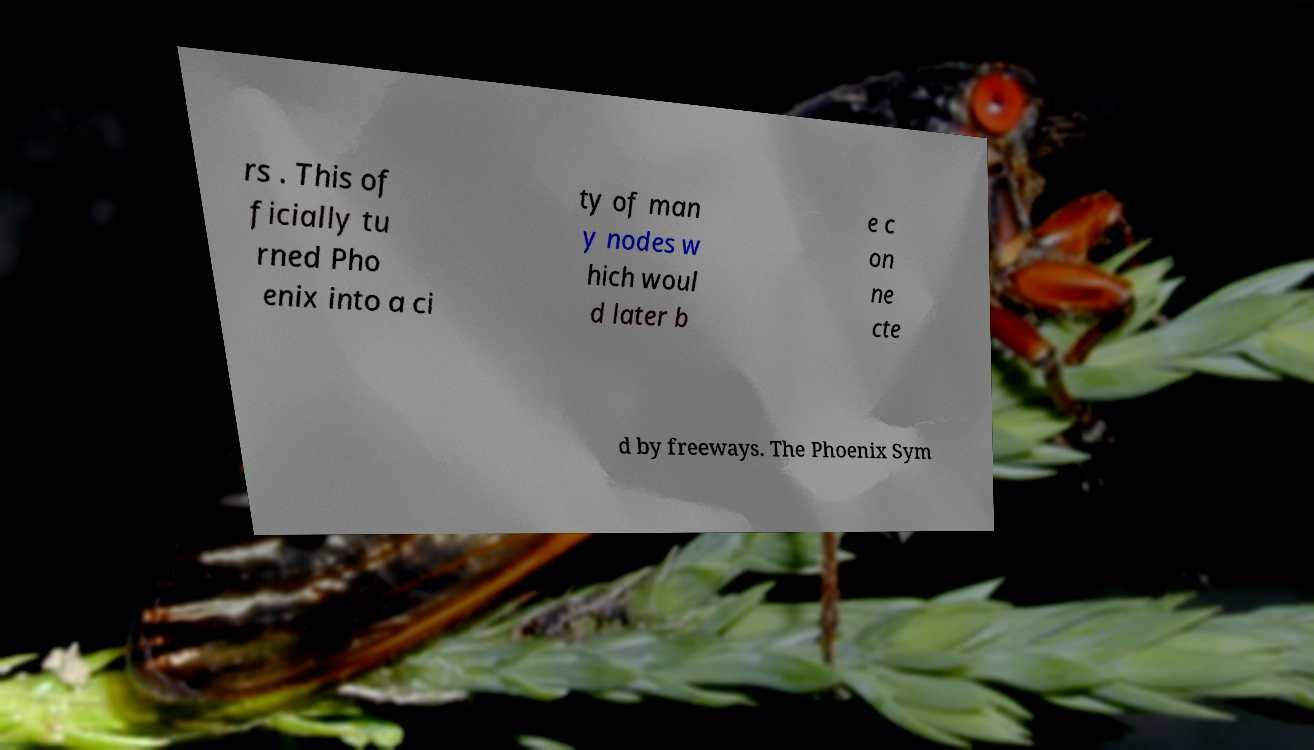What messages or text are displayed in this image? I need them in a readable, typed format. rs . This of ficially tu rned Pho enix into a ci ty of man y nodes w hich woul d later b e c on ne cte d by freeways. The Phoenix Sym 